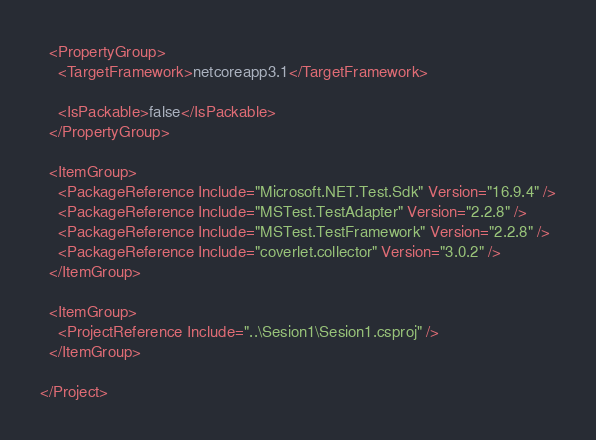Convert code to text. <code><loc_0><loc_0><loc_500><loc_500><_XML_>
  <PropertyGroup>
    <TargetFramework>netcoreapp3.1</TargetFramework>

    <IsPackable>false</IsPackable>
  </PropertyGroup>

  <ItemGroup>
    <PackageReference Include="Microsoft.NET.Test.Sdk" Version="16.9.4" />
    <PackageReference Include="MSTest.TestAdapter" Version="2.2.8" />
    <PackageReference Include="MSTest.TestFramework" Version="2.2.8" />
    <PackageReference Include="coverlet.collector" Version="3.0.2" />
  </ItemGroup>

  <ItemGroup>
    <ProjectReference Include="..\Sesion1\Sesion1.csproj" />
  </ItemGroup>

</Project>
</code> 